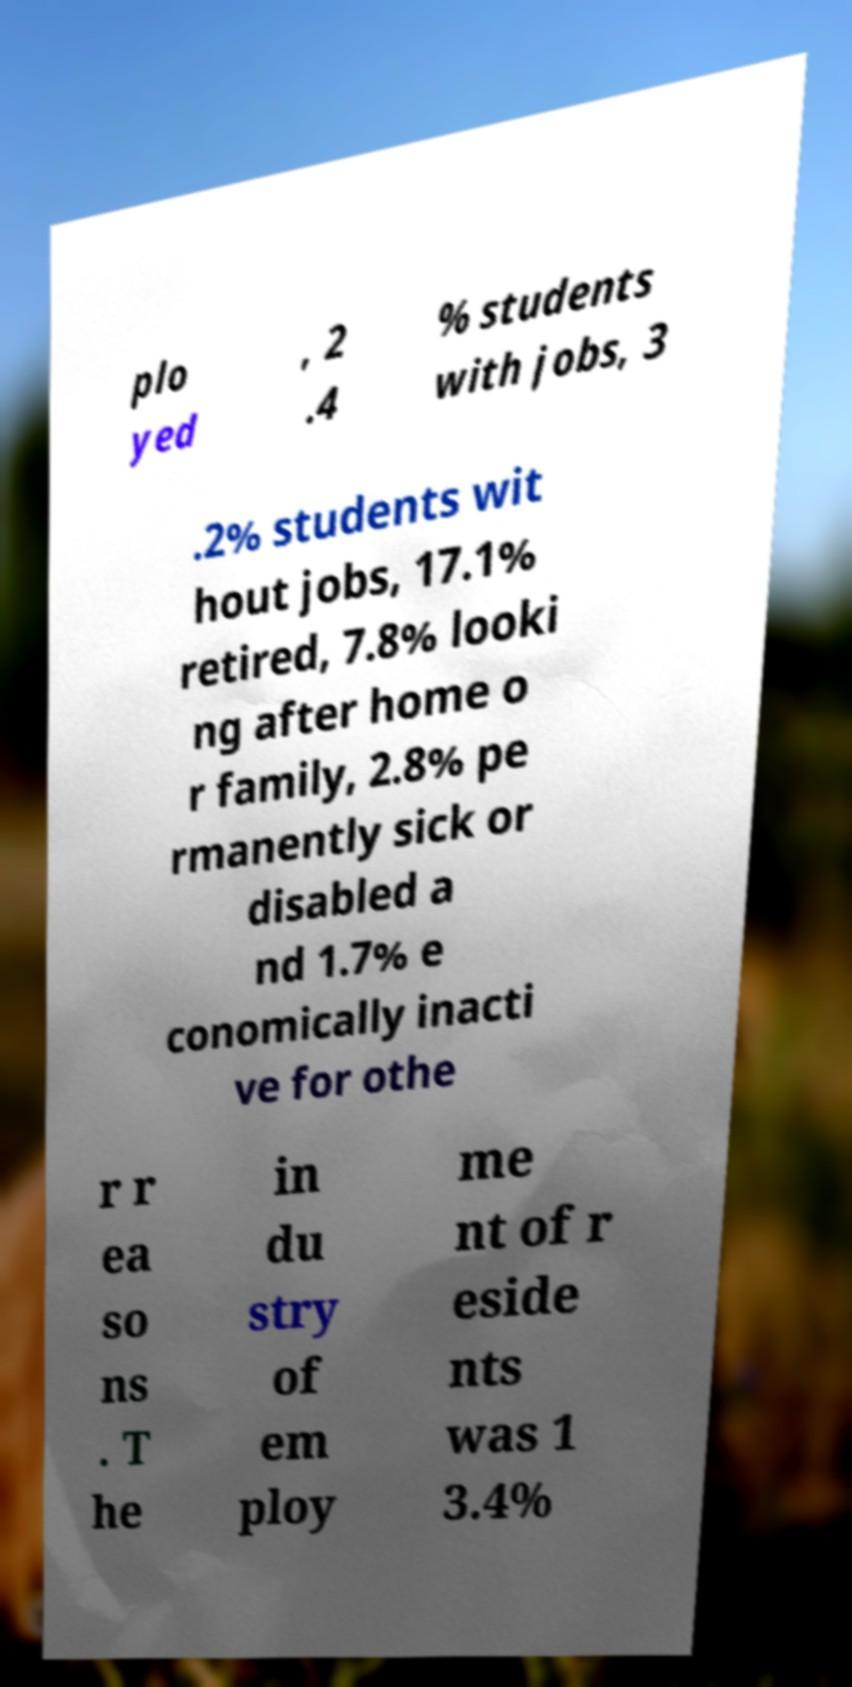Can you accurately transcribe the text from the provided image for me? plo yed , 2 .4 % students with jobs, 3 .2% students wit hout jobs, 17.1% retired, 7.8% looki ng after home o r family, 2.8% pe rmanently sick or disabled a nd 1.7% e conomically inacti ve for othe r r ea so ns . T he in du stry of em ploy me nt of r eside nts was 1 3.4% 